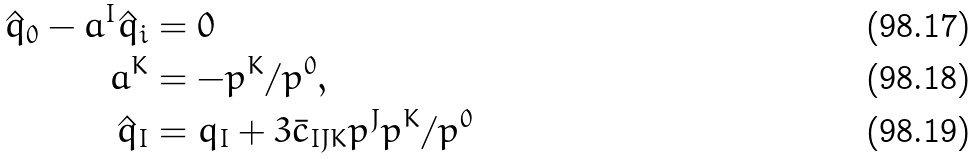Convert formula to latex. <formula><loc_0><loc_0><loc_500><loc_500>\hat { q } _ { 0 } - a ^ { I } \hat { q } _ { i } & = 0 \\ a ^ { K } & = - p ^ { K } / p ^ { 0 } , \\ \hat { q } _ { I } & = q _ { I } + 3 { \bar { c } } _ { I J K } p ^ { J } p ^ { K } / p ^ { 0 }</formula> 